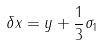Convert formula to latex. <formula><loc_0><loc_0><loc_500><loc_500>\delta x = y + \frac { 1 } { 3 } \sigma _ { 1 }</formula> 